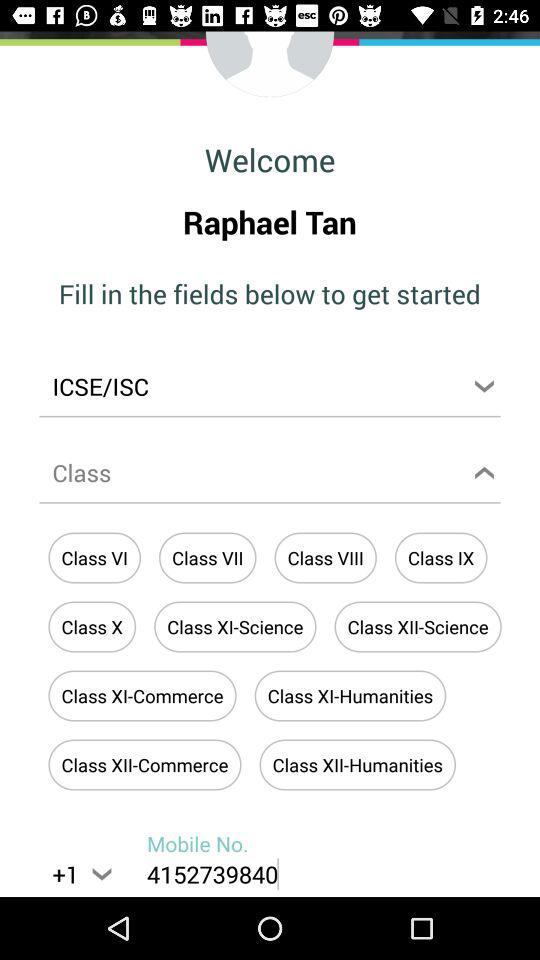Which class is selected?
When the provided information is insufficient, respond with <no answer>. <no answer> 